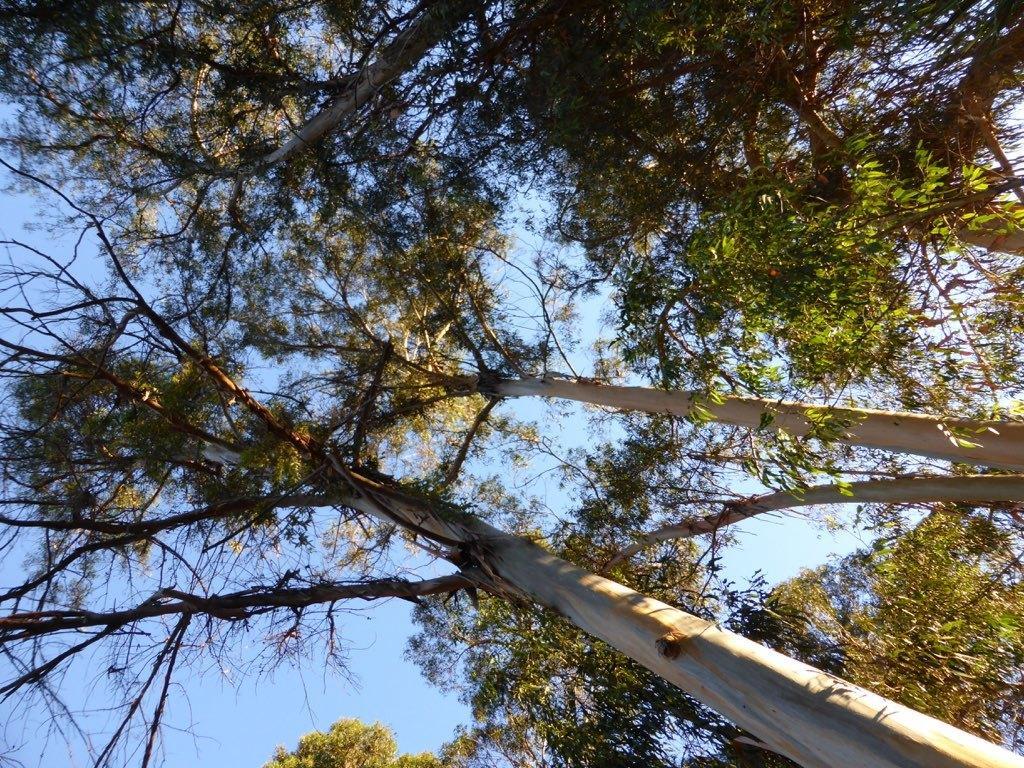Can you describe this image briefly? In this image I can see number of trees and the sky in the background. 